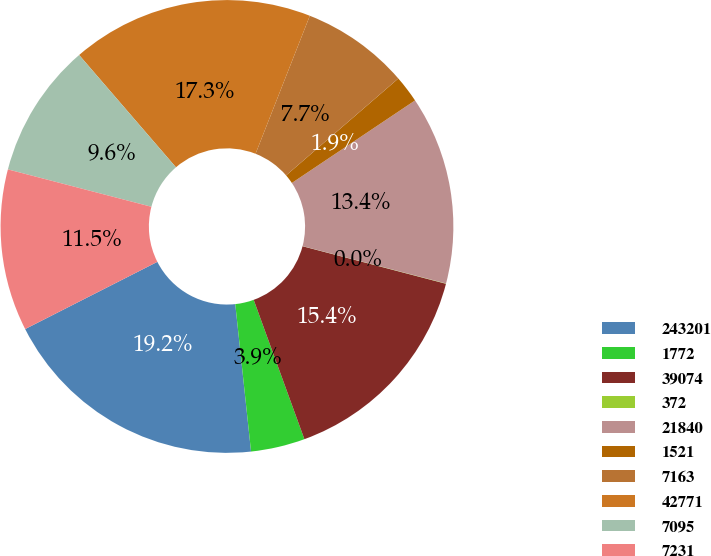Convert chart to OTSL. <chart><loc_0><loc_0><loc_500><loc_500><pie_chart><fcel>243201<fcel>1772<fcel>39074<fcel>372<fcel>21840<fcel>1521<fcel>7163<fcel>42771<fcel>7095<fcel>7231<nl><fcel>19.21%<fcel>3.86%<fcel>15.37%<fcel>0.02%<fcel>13.45%<fcel>1.94%<fcel>7.7%<fcel>17.29%<fcel>9.62%<fcel>11.54%<nl></chart> 